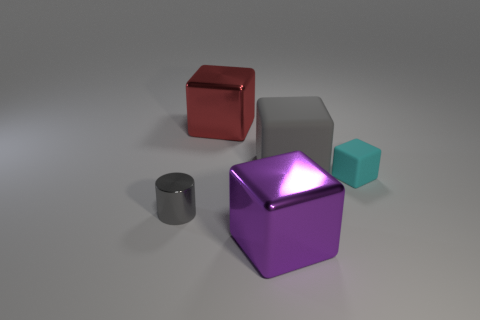Subtract all large rubber cubes. How many cubes are left? 3 Subtract all cyan blocks. How many blocks are left? 3 Subtract 2 blocks. How many blocks are left? 2 Add 4 big purple things. How many objects exist? 9 Add 4 large objects. How many large objects exist? 7 Subtract 0 brown spheres. How many objects are left? 5 Subtract all cylinders. How many objects are left? 4 Subtract all yellow cubes. Subtract all cyan cylinders. How many cubes are left? 4 Subtract all gray matte blocks. Subtract all tiny red metal objects. How many objects are left? 4 Add 5 big shiny cubes. How many big shiny cubes are left? 7 